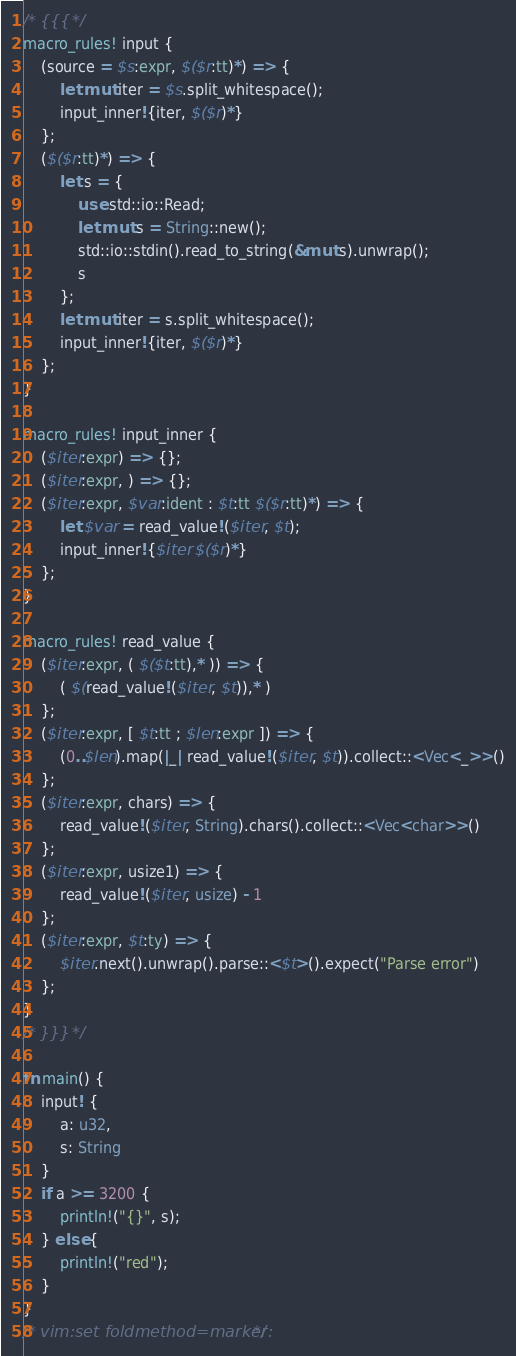Convert code to text. <code><loc_0><loc_0><loc_500><loc_500><_Rust_>/* {{{ */
macro_rules! input {
    (source = $s:expr, $($r:tt)*) => {
        let mut iter = $s.split_whitespace();
        input_inner!{iter, $($r)*}
    };
    ($($r:tt)*) => {
        let s = {
            use std::io::Read;
            let mut s = String::new();
            std::io::stdin().read_to_string(&mut s).unwrap();
            s
        };
        let mut iter = s.split_whitespace();
        input_inner!{iter, $($r)*}
    };
}

macro_rules! input_inner {
    ($iter:expr) => {};
    ($iter:expr, ) => {};
    ($iter:expr, $var:ident : $t:tt $($r:tt)*) => {
        let $var = read_value!($iter, $t);
        input_inner!{$iter $($r)*}
    };
}

macro_rules! read_value {
    ($iter:expr, ( $($t:tt),* )) => {
        ( $(read_value!($iter, $t)),* )
    };
    ($iter:expr, [ $t:tt ; $len:expr ]) => {
        (0..$len).map(|_| read_value!($iter, $t)).collect::<Vec<_>>()
    };
    ($iter:expr, chars) => {
        read_value!($iter, String).chars().collect::<Vec<char>>()
    };
    ($iter:expr, usize1) => {
        read_value!($iter, usize) - 1
    };
    ($iter:expr, $t:ty) => {
        $iter.next().unwrap().parse::<$t>().expect("Parse error")
    };
}
/* }}} */

fn main() {
    input! {
        a: u32,
        s: String
    }
    if a >= 3200 {
        println!("{}", s);
    } else {
        println!("red");
    }
}
/* vim:set foldmethod=marker: */
</code> 